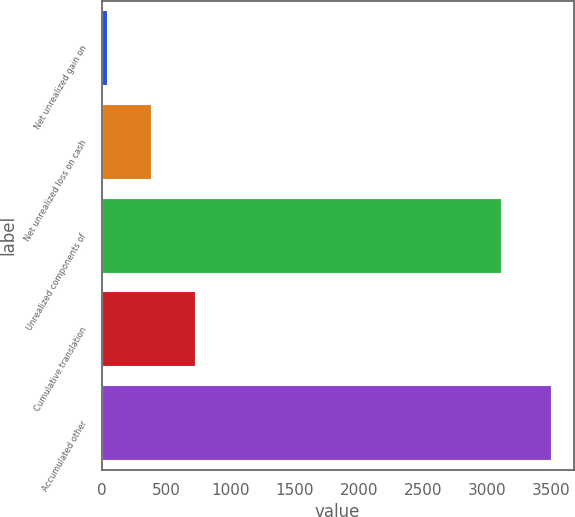Convert chart to OTSL. <chart><loc_0><loc_0><loc_500><loc_500><bar_chart><fcel>Net unrealized gain on<fcel>Net unrealized loss on cash<fcel>Unrealized components of<fcel>Cumulative translation<fcel>Accumulated other<nl><fcel>37<fcel>383.1<fcel>3109<fcel>729.2<fcel>3498<nl></chart> 